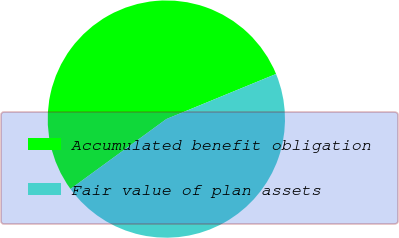Convert chart to OTSL. <chart><loc_0><loc_0><loc_500><loc_500><pie_chart><fcel>Accumulated benefit obligation<fcel>Fair value of plan assets<nl><fcel>53.82%<fcel>46.18%<nl></chart> 